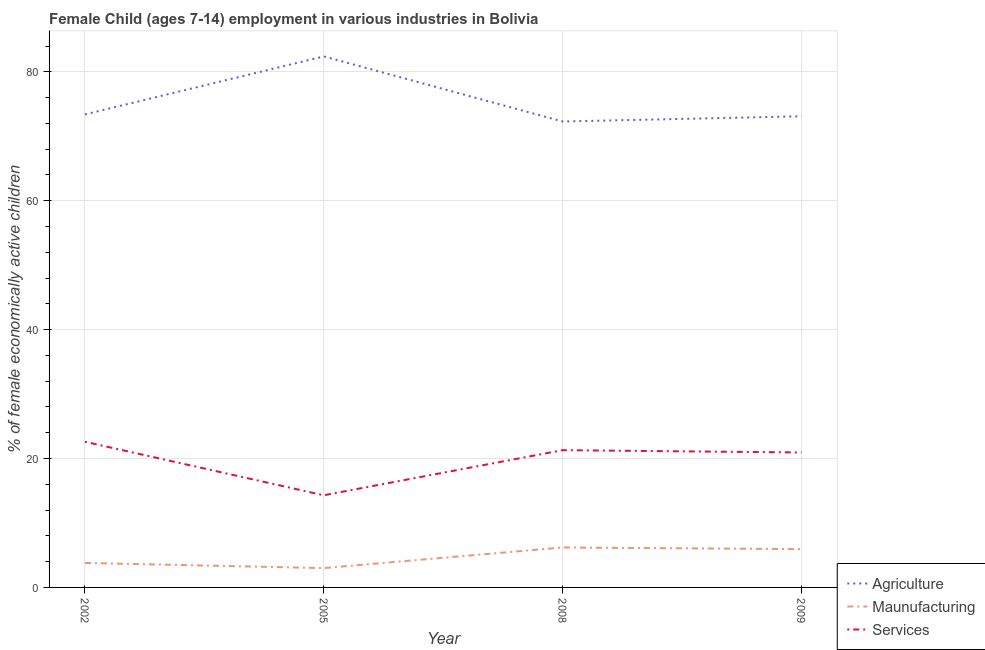How many different coloured lines are there?
Give a very brief answer. 3. Does the line corresponding to percentage of economically active children in services intersect with the line corresponding to percentage of economically active children in manufacturing?
Ensure brevity in your answer.  No. Is the number of lines equal to the number of legend labels?
Make the answer very short. Yes. What is the percentage of economically active children in agriculture in 2005?
Keep it short and to the point. 82.4. Across all years, what is the minimum percentage of economically active children in services?
Provide a succinct answer. 14.3. In which year was the percentage of economically active children in manufacturing minimum?
Provide a succinct answer. 2005. What is the total percentage of economically active children in manufacturing in the graph?
Your answer should be very brief. 18.94. What is the difference between the percentage of economically active children in manufacturing in 2008 and that in 2009?
Offer a very short reply. 0.26. What is the difference between the percentage of economically active children in agriculture in 2005 and the percentage of economically active children in services in 2002?
Provide a succinct answer. 59.8. What is the average percentage of economically active children in manufacturing per year?
Offer a terse response. 4.74. In the year 2002, what is the difference between the percentage of economically active children in agriculture and percentage of economically active children in manufacturing?
Provide a short and direct response. 69.6. In how many years, is the percentage of economically active children in manufacturing greater than 12 %?
Offer a very short reply. 0. What is the ratio of the percentage of economically active children in manufacturing in 2002 to that in 2005?
Offer a terse response. 1.27. Is the difference between the percentage of economically active children in agriculture in 2002 and 2008 greater than the difference between the percentage of economically active children in manufacturing in 2002 and 2008?
Offer a very short reply. Yes. What is the difference between the highest and the second highest percentage of economically active children in agriculture?
Make the answer very short. 9. What is the difference between the highest and the lowest percentage of economically active children in agriculture?
Your response must be concise. 10.1. Is it the case that in every year, the sum of the percentage of economically active children in agriculture and percentage of economically active children in manufacturing is greater than the percentage of economically active children in services?
Offer a terse response. Yes. Is the percentage of economically active children in manufacturing strictly less than the percentage of economically active children in services over the years?
Offer a terse response. Yes. How many lines are there?
Ensure brevity in your answer.  3. What is the difference between two consecutive major ticks on the Y-axis?
Keep it short and to the point. 20. Does the graph contain grids?
Provide a succinct answer. Yes. Where does the legend appear in the graph?
Provide a succinct answer. Bottom right. How are the legend labels stacked?
Offer a terse response. Vertical. What is the title of the graph?
Ensure brevity in your answer.  Female Child (ages 7-14) employment in various industries in Bolivia. Does "Capital account" appear as one of the legend labels in the graph?
Provide a short and direct response. No. What is the label or title of the X-axis?
Offer a very short reply. Year. What is the label or title of the Y-axis?
Provide a succinct answer. % of female economically active children. What is the % of female economically active children in Agriculture in 2002?
Ensure brevity in your answer.  73.4. What is the % of female economically active children in Services in 2002?
Ensure brevity in your answer.  22.6. What is the % of female economically active children in Agriculture in 2005?
Keep it short and to the point. 82.4. What is the % of female economically active children of Services in 2005?
Offer a very short reply. 14.3. What is the % of female economically active children in Agriculture in 2008?
Your answer should be compact. 72.3. What is the % of female economically active children in Maunufacturing in 2008?
Your response must be concise. 6.2. What is the % of female economically active children in Services in 2008?
Your answer should be very brief. 21.3. What is the % of female economically active children of Agriculture in 2009?
Keep it short and to the point. 73.11. What is the % of female economically active children of Maunufacturing in 2009?
Keep it short and to the point. 5.94. What is the % of female economically active children of Services in 2009?
Your answer should be very brief. 20.94. Across all years, what is the maximum % of female economically active children of Agriculture?
Keep it short and to the point. 82.4. Across all years, what is the maximum % of female economically active children in Services?
Ensure brevity in your answer.  22.6. Across all years, what is the minimum % of female economically active children in Agriculture?
Offer a very short reply. 72.3. Across all years, what is the minimum % of female economically active children of Maunufacturing?
Keep it short and to the point. 3. What is the total % of female economically active children of Agriculture in the graph?
Your answer should be compact. 301.21. What is the total % of female economically active children of Maunufacturing in the graph?
Offer a terse response. 18.94. What is the total % of female economically active children in Services in the graph?
Provide a succinct answer. 79.14. What is the difference between the % of female economically active children in Agriculture in 2002 and that in 2005?
Make the answer very short. -9. What is the difference between the % of female economically active children of Agriculture in 2002 and that in 2008?
Offer a very short reply. 1.1. What is the difference between the % of female economically active children in Agriculture in 2002 and that in 2009?
Make the answer very short. 0.29. What is the difference between the % of female economically active children of Maunufacturing in 2002 and that in 2009?
Your answer should be very brief. -2.14. What is the difference between the % of female economically active children in Services in 2002 and that in 2009?
Your response must be concise. 1.66. What is the difference between the % of female economically active children in Agriculture in 2005 and that in 2008?
Offer a terse response. 10.1. What is the difference between the % of female economically active children of Services in 2005 and that in 2008?
Offer a very short reply. -7. What is the difference between the % of female economically active children in Agriculture in 2005 and that in 2009?
Your answer should be very brief. 9.29. What is the difference between the % of female economically active children of Maunufacturing in 2005 and that in 2009?
Keep it short and to the point. -2.94. What is the difference between the % of female economically active children of Services in 2005 and that in 2009?
Your answer should be compact. -6.64. What is the difference between the % of female economically active children of Agriculture in 2008 and that in 2009?
Your answer should be very brief. -0.81. What is the difference between the % of female economically active children of Maunufacturing in 2008 and that in 2009?
Keep it short and to the point. 0.26. What is the difference between the % of female economically active children of Services in 2008 and that in 2009?
Make the answer very short. 0.36. What is the difference between the % of female economically active children of Agriculture in 2002 and the % of female economically active children of Maunufacturing in 2005?
Offer a very short reply. 70.4. What is the difference between the % of female economically active children in Agriculture in 2002 and the % of female economically active children in Services in 2005?
Give a very brief answer. 59.1. What is the difference between the % of female economically active children of Maunufacturing in 2002 and the % of female economically active children of Services in 2005?
Offer a very short reply. -10.5. What is the difference between the % of female economically active children in Agriculture in 2002 and the % of female economically active children in Maunufacturing in 2008?
Make the answer very short. 67.2. What is the difference between the % of female economically active children of Agriculture in 2002 and the % of female economically active children of Services in 2008?
Your answer should be very brief. 52.1. What is the difference between the % of female economically active children in Maunufacturing in 2002 and the % of female economically active children in Services in 2008?
Keep it short and to the point. -17.5. What is the difference between the % of female economically active children in Agriculture in 2002 and the % of female economically active children in Maunufacturing in 2009?
Ensure brevity in your answer.  67.46. What is the difference between the % of female economically active children in Agriculture in 2002 and the % of female economically active children in Services in 2009?
Offer a very short reply. 52.46. What is the difference between the % of female economically active children of Maunufacturing in 2002 and the % of female economically active children of Services in 2009?
Your response must be concise. -17.14. What is the difference between the % of female economically active children in Agriculture in 2005 and the % of female economically active children in Maunufacturing in 2008?
Offer a terse response. 76.2. What is the difference between the % of female economically active children in Agriculture in 2005 and the % of female economically active children in Services in 2008?
Make the answer very short. 61.1. What is the difference between the % of female economically active children in Maunufacturing in 2005 and the % of female economically active children in Services in 2008?
Your answer should be compact. -18.3. What is the difference between the % of female economically active children of Agriculture in 2005 and the % of female economically active children of Maunufacturing in 2009?
Your answer should be compact. 76.46. What is the difference between the % of female economically active children of Agriculture in 2005 and the % of female economically active children of Services in 2009?
Provide a succinct answer. 61.46. What is the difference between the % of female economically active children in Maunufacturing in 2005 and the % of female economically active children in Services in 2009?
Provide a succinct answer. -17.94. What is the difference between the % of female economically active children in Agriculture in 2008 and the % of female economically active children in Maunufacturing in 2009?
Provide a short and direct response. 66.36. What is the difference between the % of female economically active children of Agriculture in 2008 and the % of female economically active children of Services in 2009?
Keep it short and to the point. 51.36. What is the difference between the % of female economically active children of Maunufacturing in 2008 and the % of female economically active children of Services in 2009?
Your answer should be compact. -14.74. What is the average % of female economically active children of Agriculture per year?
Offer a very short reply. 75.3. What is the average % of female economically active children in Maunufacturing per year?
Your answer should be very brief. 4.74. What is the average % of female economically active children of Services per year?
Offer a very short reply. 19.79. In the year 2002, what is the difference between the % of female economically active children of Agriculture and % of female economically active children of Maunufacturing?
Give a very brief answer. 69.6. In the year 2002, what is the difference between the % of female economically active children of Agriculture and % of female economically active children of Services?
Give a very brief answer. 50.8. In the year 2002, what is the difference between the % of female economically active children of Maunufacturing and % of female economically active children of Services?
Offer a very short reply. -18.8. In the year 2005, what is the difference between the % of female economically active children in Agriculture and % of female economically active children in Maunufacturing?
Your answer should be compact. 79.4. In the year 2005, what is the difference between the % of female economically active children in Agriculture and % of female economically active children in Services?
Ensure brevity in your answer.  68.1. In the year 2008, what is the difference between the % of female economically active children of Agriculture and % of female economically active children of Maunufacturing?
Offer a very short reply. 66.1. In the year 2008, what is the difference between the % of female economically active children of Agriculture and % of female economically active children of Services?
Offer a terse response. 51. In the year 2008, what is the difference between the % of female economically active children in Maunufacturing and % of female economically active children in Services?
Provide a succinct answer. -15.1. In the year 2009, what is the difference between the % of female economically active children in Agriculture and % of female economically active children in Maunufacturing?
Give a very brief answer. 67.17. In the year 2009, what is the difference between the % of female economically active children in Agriculture and % of female economically active children in Services?
Provide a succinct answer. 52.17. In the year 2009, what is the difference between the % of female economically active children in Maunufacturing and % of female economically active children in Services?
Provide a short and direct response. -15. What is the ratio of the % of female economically active children of Agriculture in 2002 to that in 2005?
Your answer should be compact. 0.89. What is the ratio of the % of female economically active children in Maunufacturing in 2002 to that in 2005?
Ensure brevity in your answer.  1.27. What is the ratio of the % of female economically active children in Services in 2002 to that in 2005?
Keep it short and to the point. 1.58. What is the ratio of the % of female economically active children in Agriculture in 2002 to that in 2008?
Ensure brevity in your answer.  1.02. What is the ratio of the % of female economically active children in Maunufacturing in 2002 to that in 2008?
Your answer should be compact. 0.61. What is the ratio of the % of female economically active children in Services in 2002 to that in 2008?
Your response must be concise. 1.06. What is the ratio of the % of female economically active children of Maunufacturing in 2002 to that in 2009?
Provide a short and direct response. 0.64. What is the ratio of the % of female economically active children of Services in 2002 to that in 2009?
Ensure brevity in your answer.  1.08. What is the ratio of the % of female economically active children of Agriculture in 2005 to that in 2008?
Offer a very short reply. 1.14. What is the ratio of the % of female economically active children in Maunufacturing in 2005 to that in 2008?
Make the answer very short. 0.48. What is the ratio of the % of female economically active children in Services in 2005 to that in 2008?
Offer a very short reply. 0.67. What is the ratio of the % of female economically active children in Agriculture in 2005 to that in 2009?
Your answer should be compact. 1.13. What is the ratio of the % of female economically active children in Maunufacturing in 2005 to that in 2009?
Provide a succinct answer. 0.51. What is the ratio of the % of female economically active children of Services in 2005 to that in 2009?
Give a very brief answer. 0.68. What is the ratio of the % of female economically active children of Agriculture in 2008 to that in 2009?
Your answer should be compact. 0.99. What is the ratio of the % of female economically active children of Maunufacturing in 2008 to that in 2009?
Your answer should be very brief. 1.04. What is the ratio of the % of female economically active children of Services in 2008 to that in 2009?
Ensure brevity in your answer.  1.02. What is the difference between the highest and the second highest % of female economically active children in Maunufacturing?
Keep it short and to the point. 0.26. What is the difference between the highest and the lowest % of female economically active children in Maunufacturing?
Ensure brevity in your answer.  3.2. What is the difference between the highest and the lowest % of female economically active children of Services?
Ensure brevity in your answer.  8.3. 